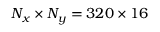<formula> <loc_0><loc_0><loc_500><loc_500>N _ { x } \times N _ { y } = 3 2 0 \times 1 6</formula> 